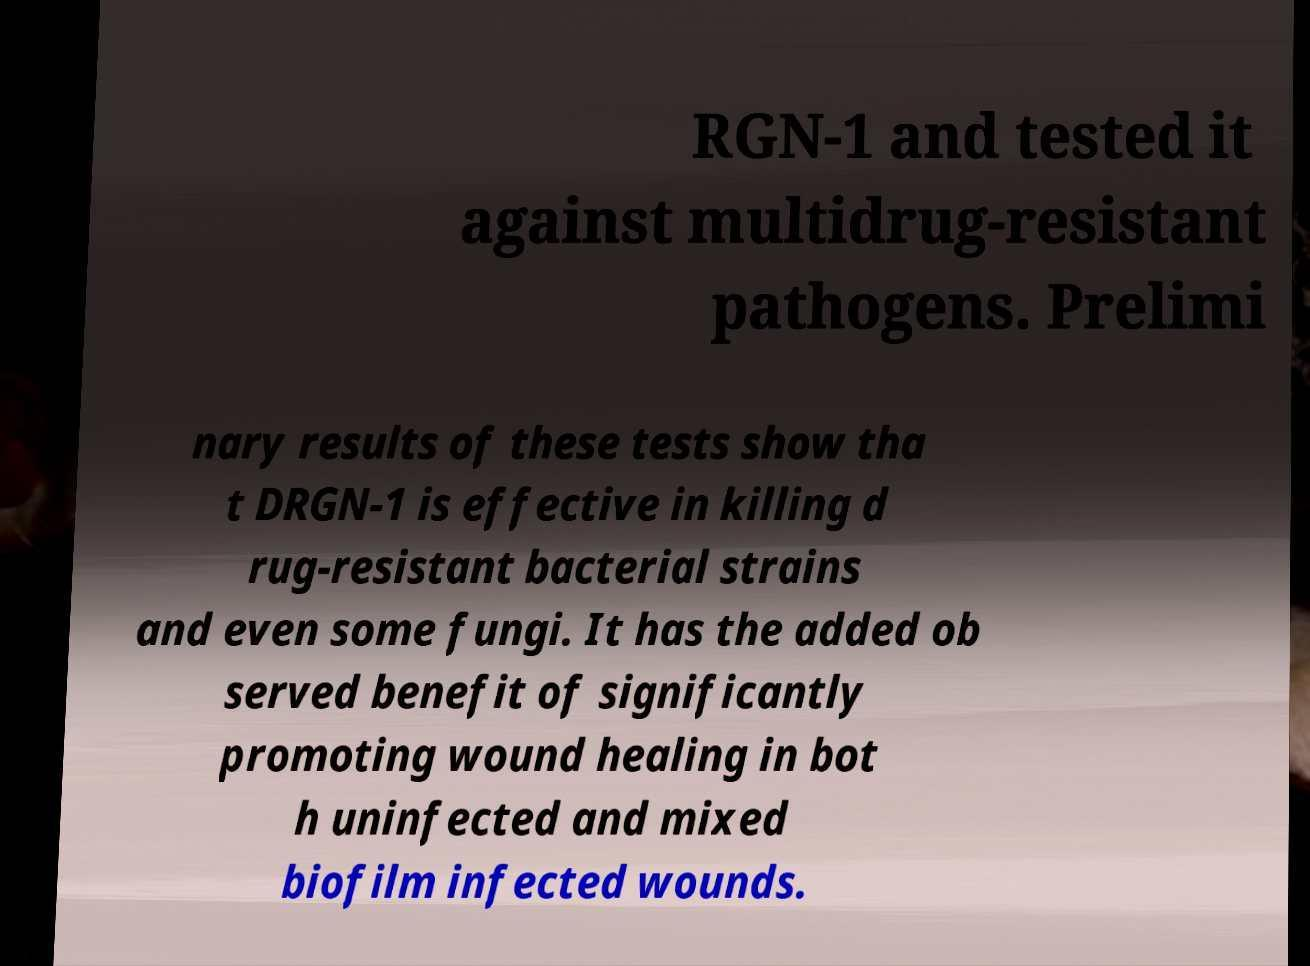Please read and relay the text visible in this image. What does it say? RGN-1 and tested it against multidrug-resistant pathogens. Prelimi nary results of these tests show tha t DRGN-1 is effective in killing d rug-resistant bacterial strains and even some fungi. It has the added ob served benefit of significantly promoting wound healing in bot h uninfected and mixed biofilm infected wounds. 